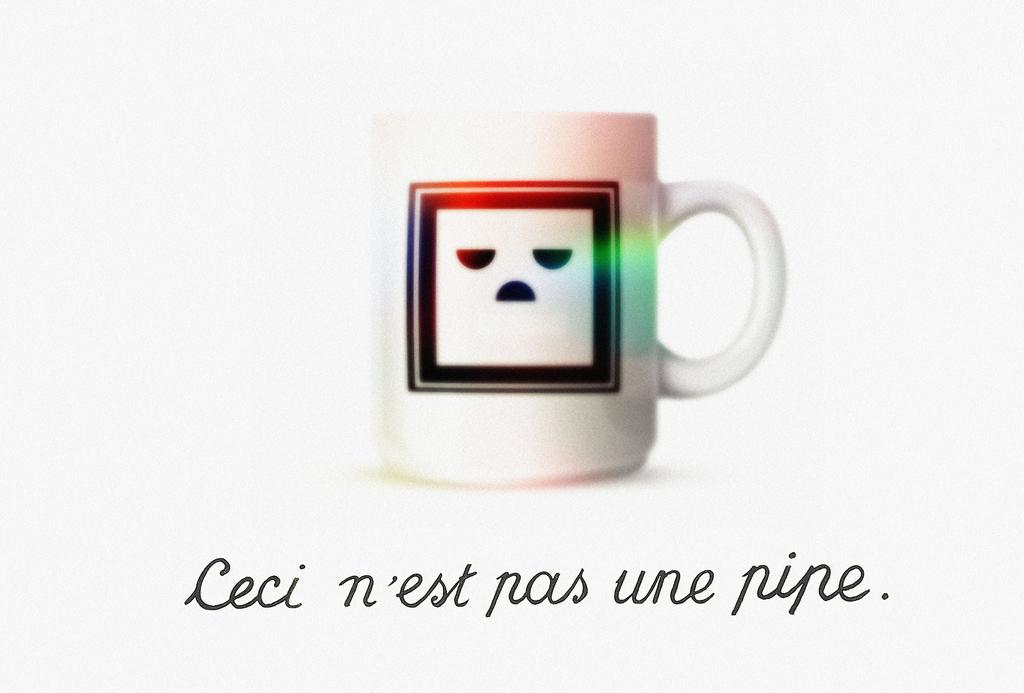What does the quote say?
Your response must be concise. Leci n'est pas une pipe. 